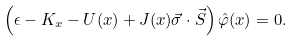Convert formula to latex. <formula><loc_0><loc_0><loc_500><loc_500>\left ( \epsilon - K _ { x } - U ( x ) + J ( x ) \vec { \sigma } \cdot \vec { S } \right ) \hat { \varphi } ( x ) = 0 .</formula> 